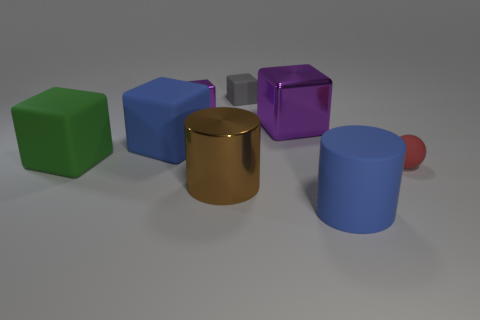What number of other blocks have the same color as the big shiny block?
Ensure brevity in your answer.  1. There is a large block that is the same color as the matte cylinder; what is its material?
Provide a succinct answer. Rubber. There is a gray object that is the same shape as the big green rubber thing; what size is it?
Keep it short and to the point. Small. Do the small shiny block and the big shiny block have the same color?
Provide a succinct answer. Yes. Is there anything else that has the same shape as the big purple metal thing?
Give a very brief answer. Yes. How many gray things are small metallic objects or blocks?
Make the answer very short. 1. Are there any green metallic cylinders?
Keep it short and to the point. No. Are there any tiny purple metallic cubes that are in front of the purple metal cube that is in front of the tiny cube that is in front of the tiny gray rubber cube?
Offer a very short reply. No. There is a large green rubber object; does it have the same shape as the purple object that is right of the gray thing?
Your answer should be very brief. Yes. What is the color of the big metal thing that is in front of the small red matte sphere that is in front of the big blue rubber object that is behind the small ball?
Your answer should be very brief. Brown. 